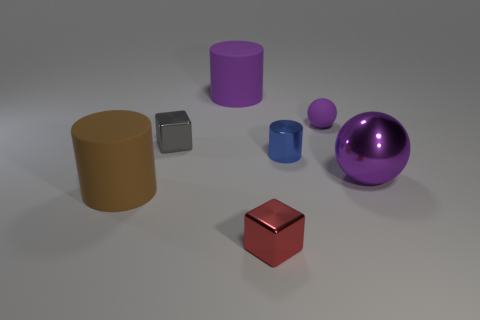There is a ball behind the shiny cube that is behind the large brown rubber cylinder; what is its size?
Provide a succinct answer. Small. There is a large object that is to the left of the big ball and in front of the tiny blue cylinder; what material is it?
Your answer should be compact. Rubber. What number of other things are there of the same size as the brown cylinder?
Give a very brief answer. 2. What color is the metallic cylinder?
Provide a short and direct response. Blue. Is the color of the shiny thing that is on the right side of the tiny shiny cylinder the same as the matte cylinder that is in front of the blue metallic cylinder?
Keep it short and to the point. No. What size is the purple shiny ball?
Provide a succinct answer. Large. How big is the thing on the left side of the tiny gray object?
Make the answer very short. Large. The big thing that is both on the left side of the big purple sphere and behind the brown thing has what shape?
Offer a terse response. Cylinder. How many other objects are there of the same shape as the purple metal object?
Your answer should be compact. 1. What color is the rubber object that is the same size as the gray block?
Provide a short and direct response. Purple. 